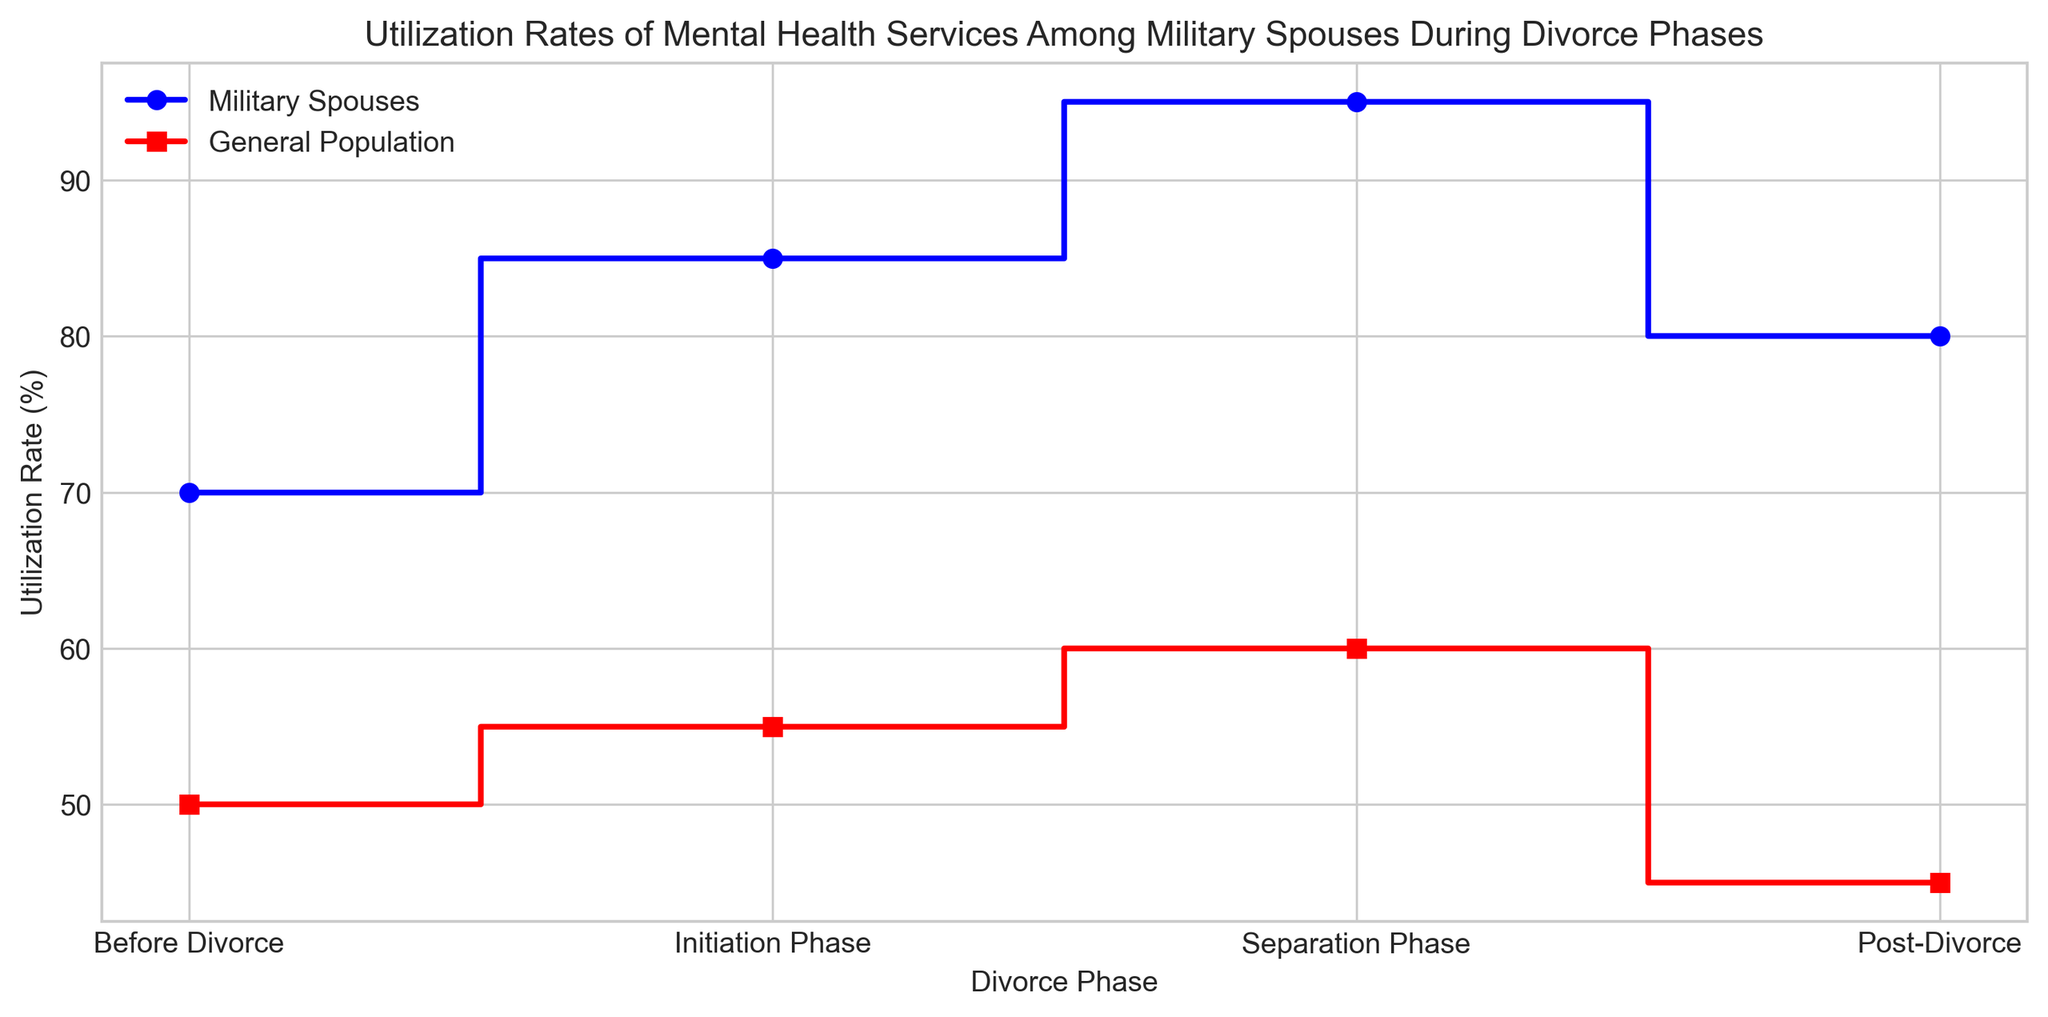Which phase had the highest utilization rate of mental health services among military spouses? Look at the step heights for military spouses and find the tallest one. The Separation Phase has the highest step.
Answer: Separation Phase During which divorce phase is the gap in utilization rates between military spouses and the general population the smallest? Compare the differences between the military spouses’ and general population’s rates in each phase. The smallest difference is before the divorce (70-50 vs 85-55 vs 95-60 vs 80-45).
Answer: Before Divorce How much did the utilization rate for military spouses increase from 'Before Divorce' to the 'Separation Phase'? Subtract the utilization rate before divorce from the rate in the separation phase (95 - 70).
Answer: 25% Which phase had the lowest utilization rate of mental health services among the general population? Look at the step heights for the general population and find the shortest one. The Post-Divorce phase has the lowest step.
Answer: Post-Divorce What is the overall trend in the utilization rates for military spouses during the different phases of divorce? Observe the sequence of steps for military spouses: before divorce to initiation to separation to post-divorce. The trend shows an increase until the separation phase, then a slight decrease post-divorce.
Answer: Increase then slight decrease By how much did the utilization rates for military spouses differ from the general population in the 'Post-Divorce' phase? Subtract the utilization rate for the general population in the post-divorce phase from that for military spouses (80 - 45).
Answer: 35% Which group saw a decrease in utilization rates post-divorce compared to the separation phase? Compare the usage rates of both groups between the separation phase and post-divorce. Both groups show a decrease.
Answer: Both What was the average utilization rate of mental health services for military spouses across all phases? Add all the utilization rates for military spouses and divide by the number of phases: (70 + 85 + 95 + 80) / 4.
Answer: 82.5% Which phase saw a steady relationship in utilization rates between the two groups? Compare the shape and closeness of the steps for both groups. Initiation Phase and Separation Phase show relatively consistent differences.
Answer: Initiation and Separation Phases 